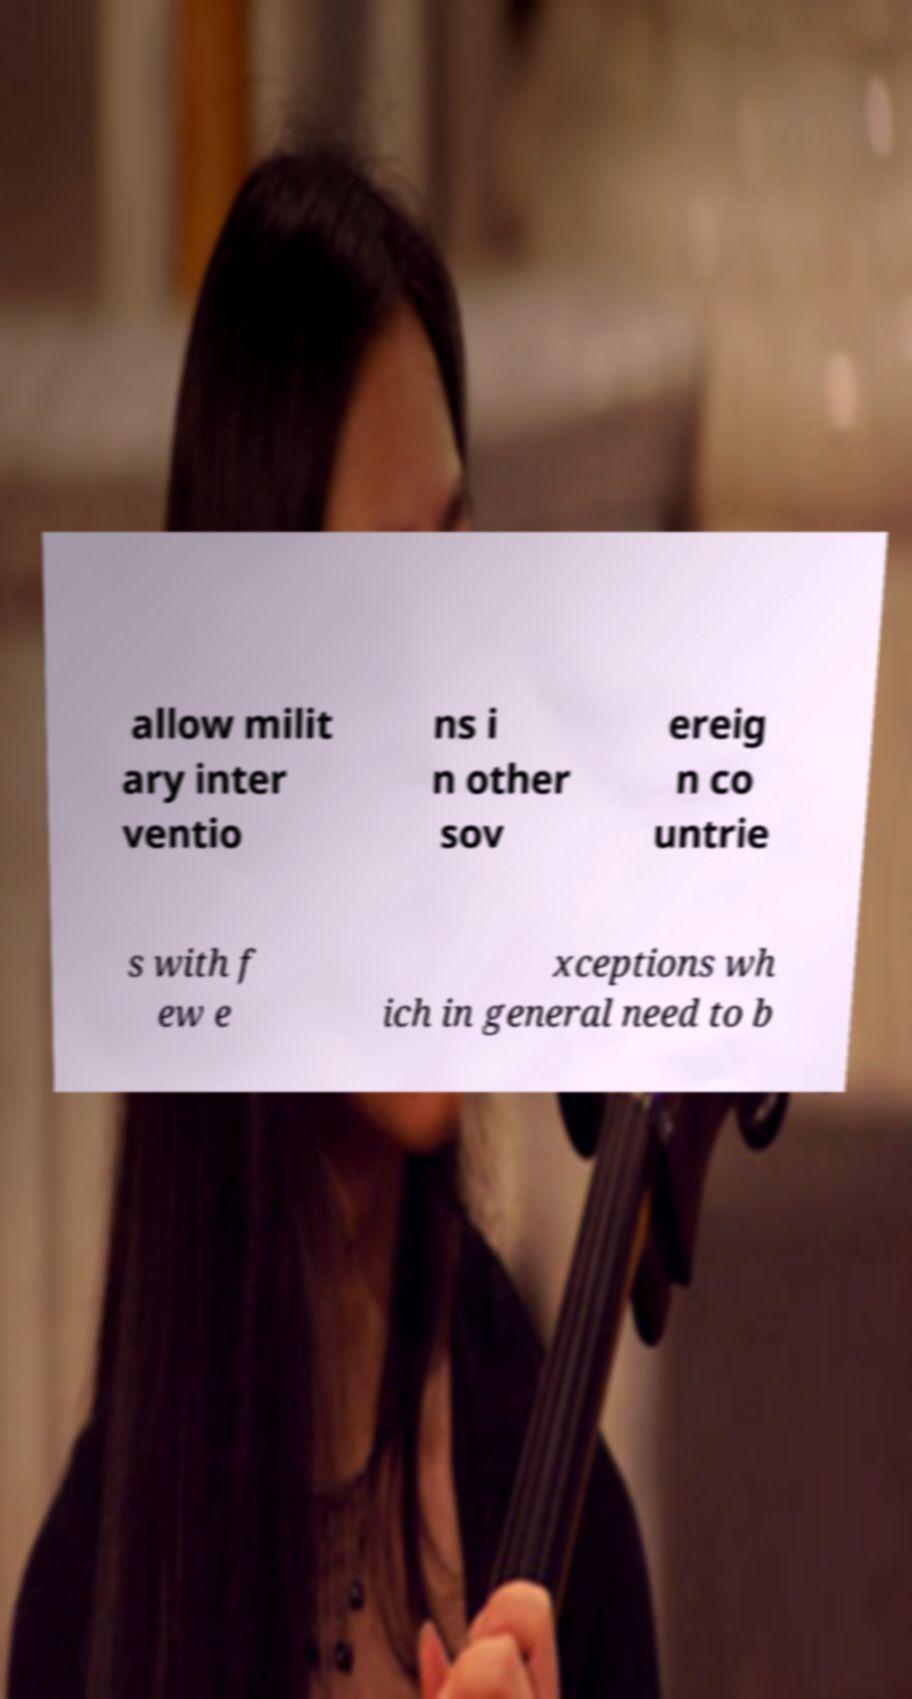Can you accurately transcribe the text from the provided image for me? allow milit ary inter ventio ns i n other sov ereig n co untrie s with f ew e xceptions wh ich in general need to b 